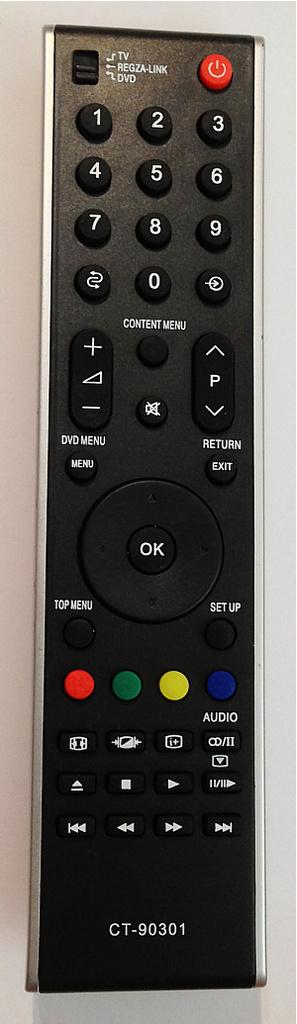<image>
Provide a brief description of the given image. a remote with the word ok in the middle 